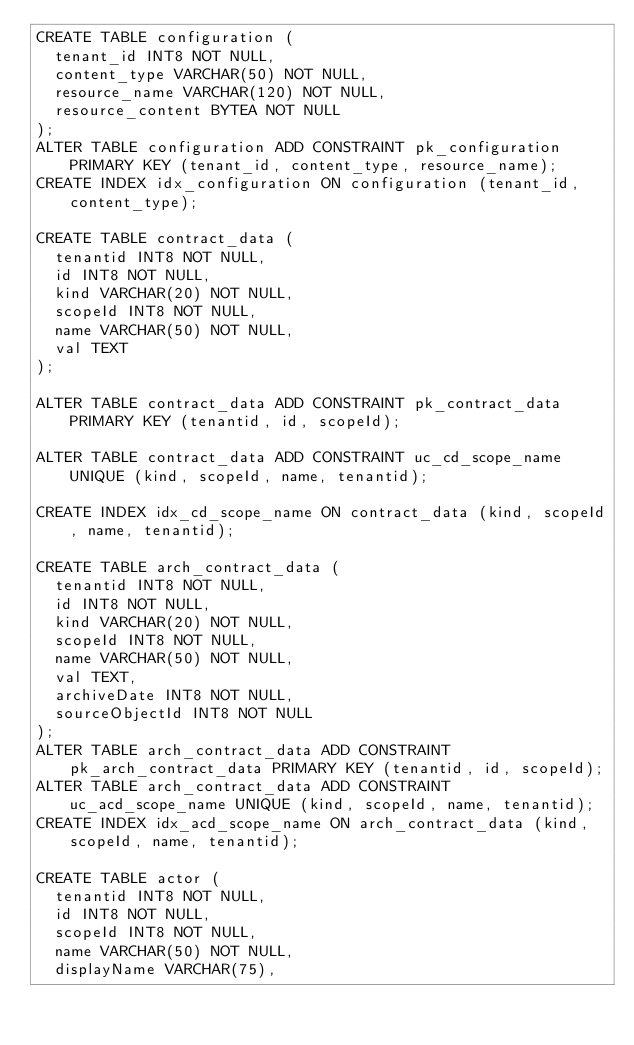<code> <loc_0><loc_0><loc_500><loc_500><_SQL_>CREATE TABLE configuration (
  tenant_id INT8 NOT NULL,
  content_type VARCHAR(50) NOT NULL,
  resource_name VARCHAR(120) NOT NULL,
  resource_content BYTEA NOT NULL
);
ALTER TABLE configuration ADD CONSTRAINT pk_configuration PRIMARY KEY (tenant_id, content_type, resource_name);
CREATE INDEX idx_configuration ON configuration (tenant_id, content_type);

CREATE TABLE contract_data (
  tenantid INT8 NOT NULL,
  id INT8 NOT NULL,
  kind VARCHAR(20) NOT NULL,
  scopeId INT8 NOT NULL,
  name VARCHAR(50) NOT NULL,
  val TEXT
);

ALTER TABLE contract_data ADD CONSTRAINT pk_contract_data PRIMARY KEY (tenantid, id, scopeId);

ALTER TABLE contract_data ADD CONSTRAINT uc_cd_scope_name UNIQUE (kind, scopeId, name, tenantid);

CREATE INDEX idx_cd_scope_name ON contract_data (kind, scopeId, name, tenantid);

CREATE TABLE arch_contract_data (
  tenantid INT8 NOT NULL,
  id INT8 NOT NULL,
  kind VARCHAR(20) NOT NULL,
  scopeId INT8 NOT NULL,
  name VARCHAR(50) NOT NULL,
  val TEXT,
  archiveDate INT8 NOT NULL,
  sourceObjectId INT8 NOT NULL
);
ALTER TABLE arch_contract_data ADD CONSTRAINT pk_arch_contract_data PRIMARY KEY (tenantid, id, scopeId);
ALTER TABLE arch_contract_data ADD CONSTRAINT uc_acd_scope_name UNIQUE (kind, scopeId, name, tenantid);
CREATE INDEX idx_acd_scope_name ON arch_contract_data (kind, scopeId, name, tenantid);

CREATE TABLE actor (
  tenantid INT8 NOT NULL,
  id INT8 NOT NULL,
  scopeId INT8 NOT NULL,
  name VARCHAR(50) NOT NULL,
  displayName VARCHAR(75),</code> 